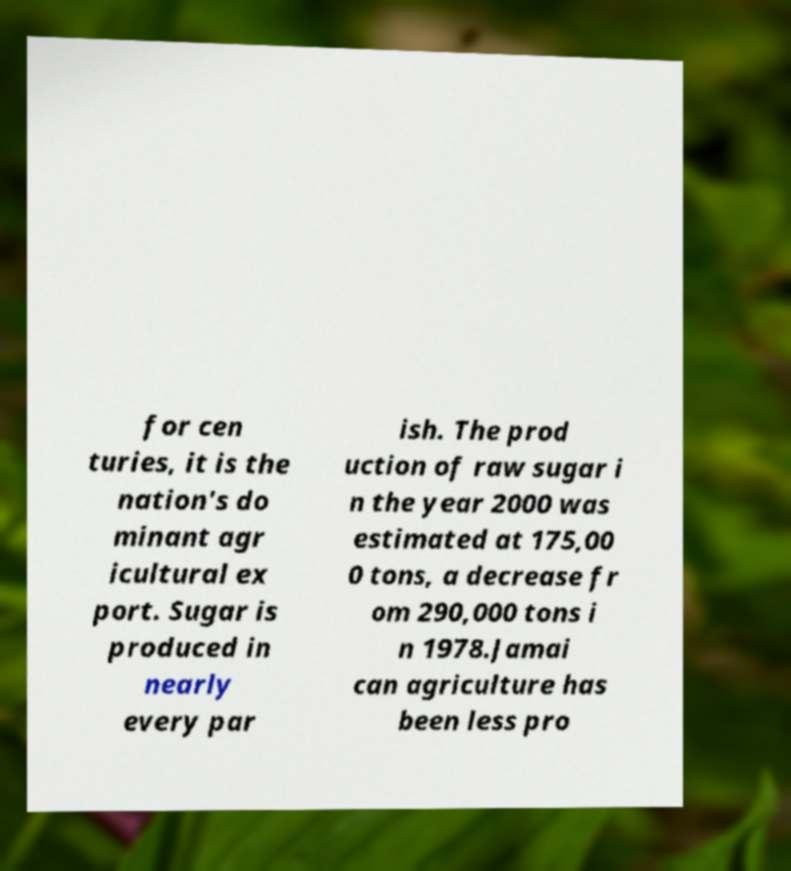Please read and relay the text visible in this image. What does it say? for cen turies, it is the nation's do minant agr icultural ex port. Sugar is produced in nearly every par ish. The prod uction of raw sugar i n the year 2000 was estimated at 175,00 0 tons, a decrease fr om 290,000 tons i n 1978.Jamai can agriculture has been less pro 